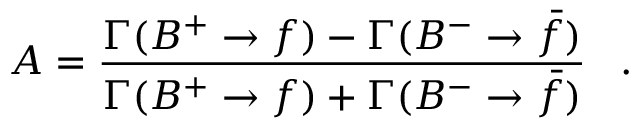<formula> <loc_0><loc_0><loc_500><loc_500>A = { \frac { \Gamma ( B ^ { + } \to f ) - \Gamma ( B ^ { - } \to \bar { f } ) } { \Gamma ( B ^ { + } \to f ) + \Gamma ( B ^ { - } \to \bar { f } ) } } \, .</formula> 